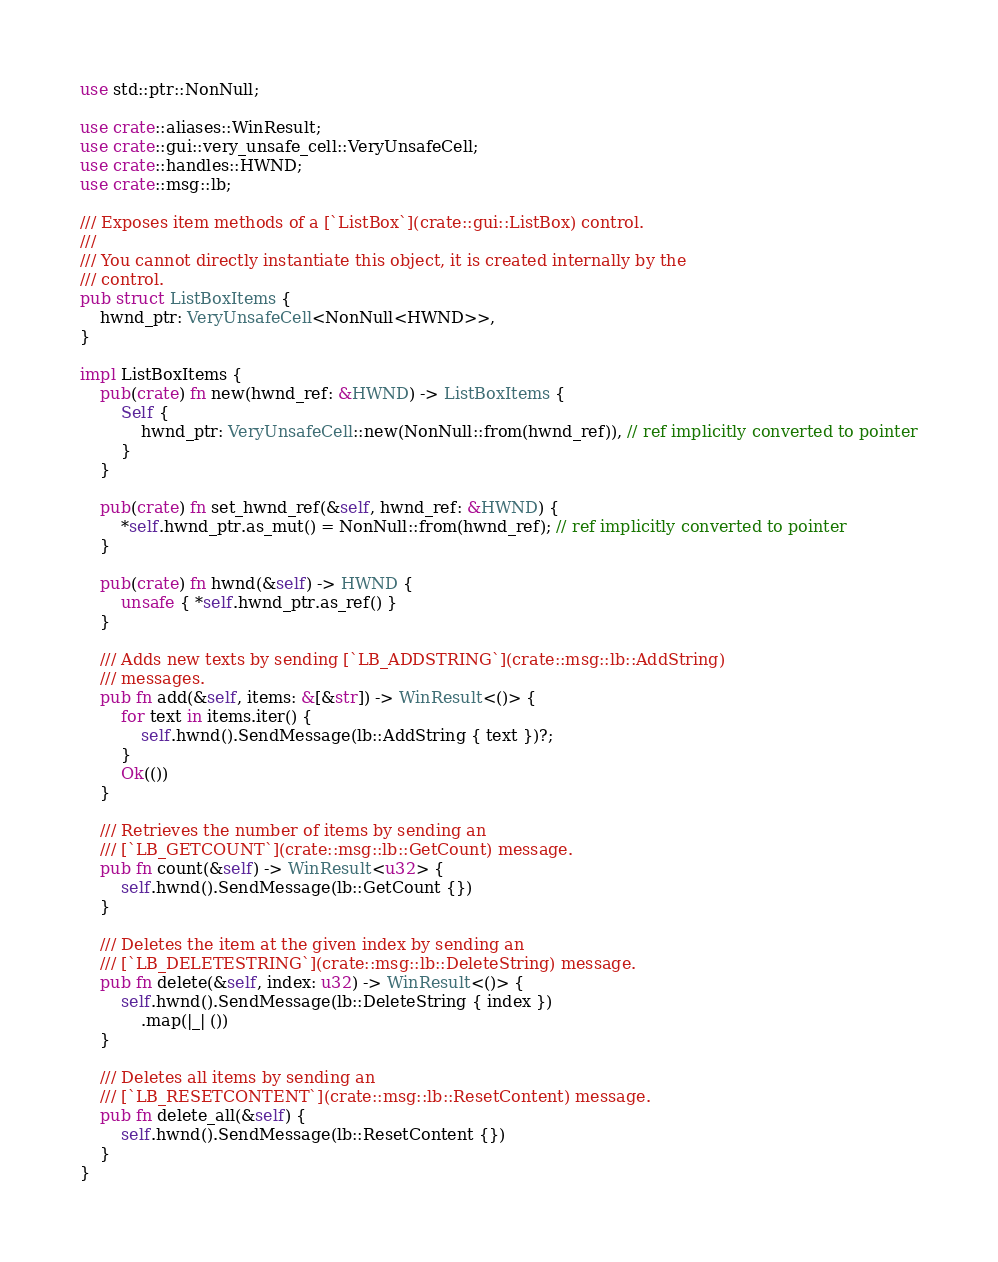Convert code to text. <code><loc_0><loc_0><loc_500><loc_500><_Rust_>use std::ptr::NonNull;

use crate::aliases::WinResult;
use crate::gui::very_unsafe_cell::VeryUnsafeCell;
use crate::handles::HWND;
use crate::msg::lb;

/// Exposes item methods of a [`ListBox`](crate::gui::ListBox) control.
///
/// You cannot directly instantiate this object, it is created internally by the
/// control.
pub struct ListBoxItems {
	hwnd_ptr: VeryUnsafeCell<NonNull<HWND>>,
}

impl ListBoxItems {
	pub(crate) fn new(hwnd_ref: &HWND) -> ListBoxItems {
		Self {
			hwnd_ptr: VeryUnsafeCell::new(NonNull::from(hwnd_ref)), // ref implicitly converted to pointer
		}
	}

	pub(crate) fn set_hwnd_ref(&self, hwnd_ref: &HWND) {
		*self.hwnd_ptr.as_mut() = NonNull::from(hwnd_ref); // ref implicitly converted to pointer
	}

	pub(crate) fn hwnd(&self) -> HWND {
		unsafe { *self.hwnd_ptr.as_ref() }
	}

	/// Adds new texts by sending [`LB_ADDSTRING`](crate::msg::lb::AddString)
	/// messages.
	pub fn add(&self, items: &[&str]) -> WinResult<()> {
		for text in items.iter() {
			self.hwnd().SendMessage(lb::AddString { text })?;
		}
		Ok(())
	}

	/// Retrieves the number of items by sending an
	/// [`LB_GETCOUNT`](crate::msg::lb::GetCount) message.
	pub fn count(&self) -> WinResult<u32> {
		self.hwnd().SendMessage(lb::GetCount {})
	}

	/// Deletes the item at the given index by sending an
	/// [`LB_DELETESTRING`](crate::msg::lb::DeleteString) message.
	pub fn delete(&self, index: u32) -> WinResult<()> {
		self.hwnd().SendMessage(lb::DeleteString { index })
			.map(|_| ())
	}

	/// Deletes all items by sending an
	/// [`LB_RESETCONTENT`](crate::msg::lb::ResetContent) message.
	pub fn delete_all(&self) {
		self.hwnd().SendMessage(lb::ResetContent {})
	}
}
</code> 